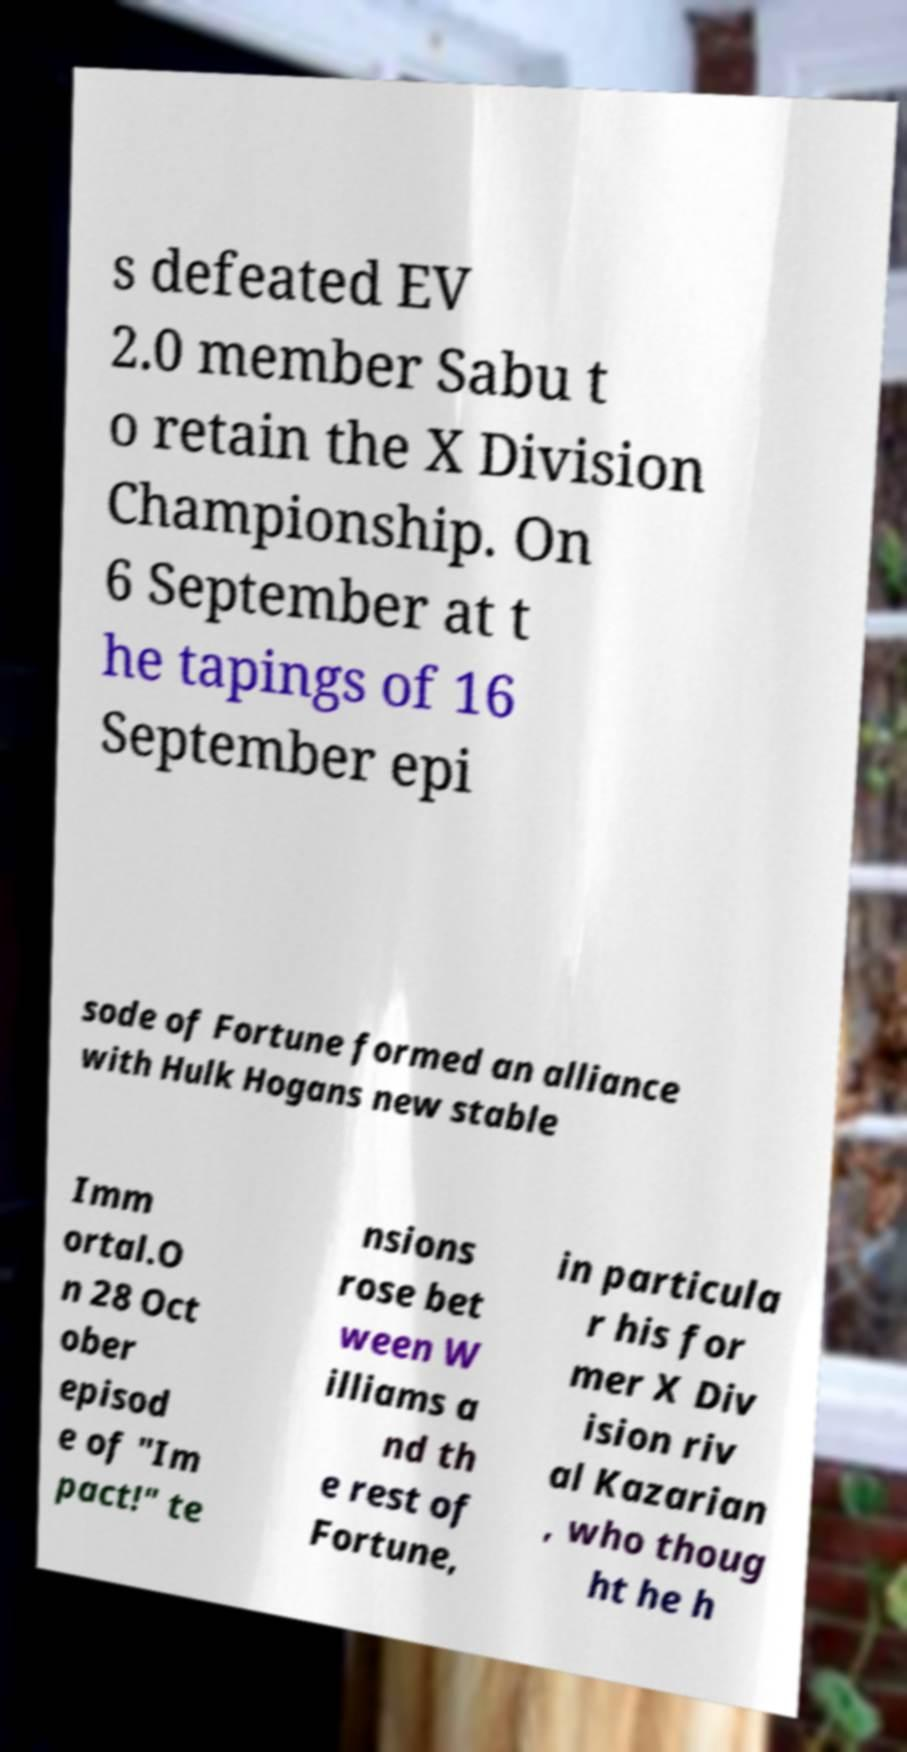What messages or text are displayed in this image? I need them in a readable, typed format. s defeated EV 2.0 member Sabu t o retain the X Division Championship. On 6 September at t he tapings of 16 September epi sode of Fortune formed an alliance with Hulk Hogans new stable Imm ortal.O n 28 Oct ober episod e of "Im pact!" te nsions rose bet ween W illiams a nd th e rest of Fortune, in particula r his for mer X Div ision riv al Kazarian , who thoug ht he h 